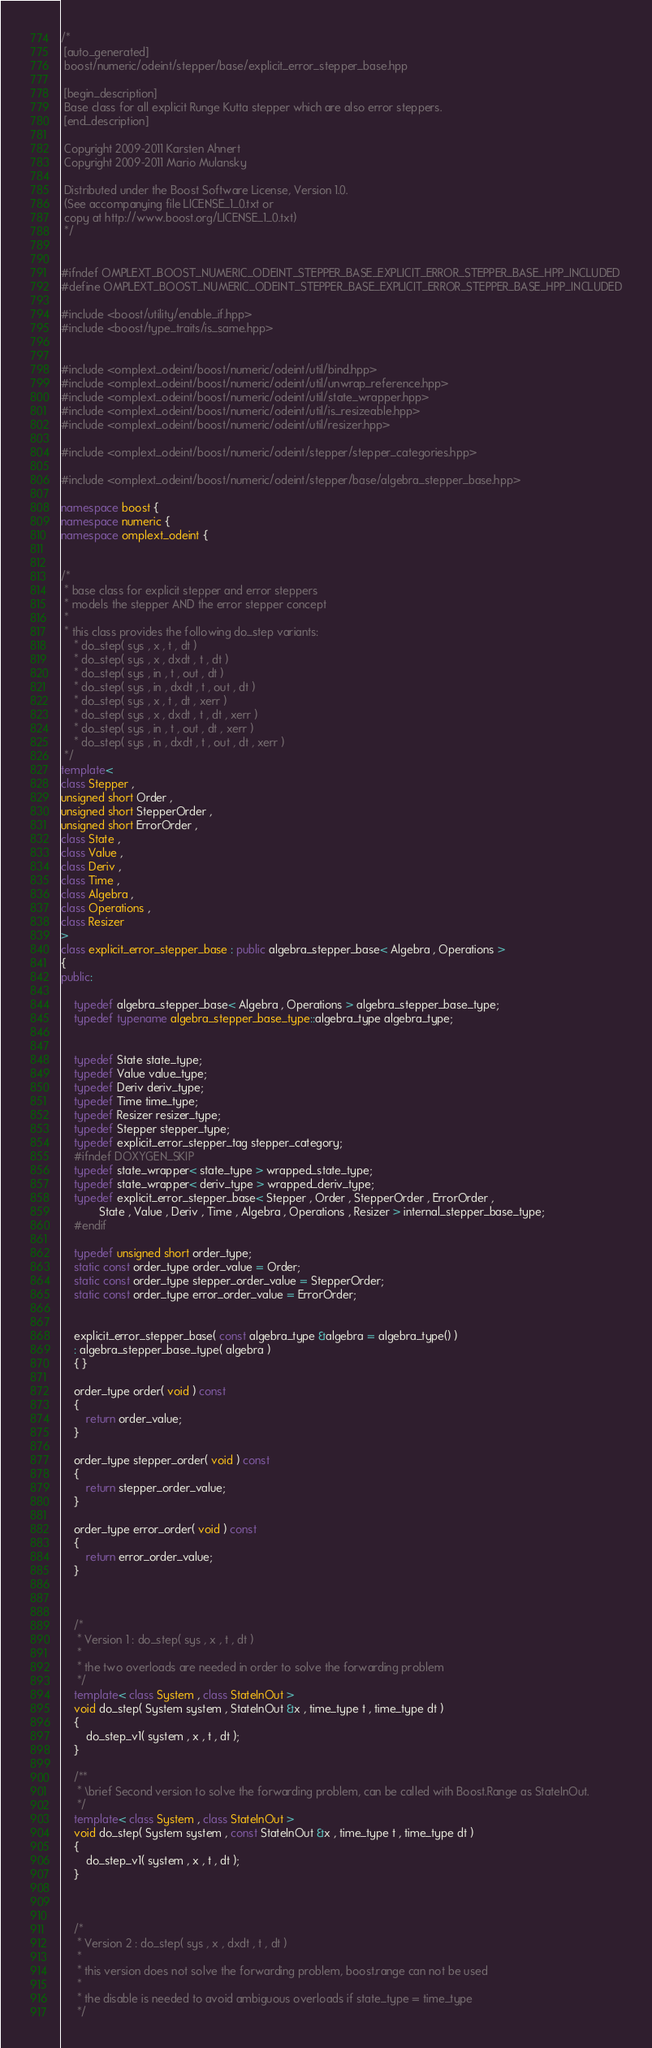<code> <loc_0><loc_0><loc_500><loc_500><_C++_>/*
 [auto_generated]
 boost/numeric/odeint/stepper/base/explicit_error_stepper_base.hpp

 [begin_description]
 Base class for all explicit Runge Kutta stepper which are also error steppers.
 [end_description]

 Copyright 2009-2011 Karsten Ahnert
 Copyright 2009-2011 Mario Mulansky

 Distributed under the Boost Software License, Version 1.0.
 (See accompanying file LICENSE_1_0.txt or
 copy at http://www.boost.org/LICENSE_1_0.txt)
 */


#ifndef OMPLEXT_BOOST_NUMERIC_ODEINT_STEPPER_BASE_EXPLICIT_ERROR_STEPPER_BASE_HPP_INCLUDED
#define OMPLEXT_BOOST_NUMERIC_ODEINT_STEPPER_BASE_EXPLICIT_ERROR_STEPPER_BASE_HPP_INCLUDED

#include <boost/utility/enable_if.hpp>
#include <boost/type_traits/is_same.hpp>


#include <omplext_odeint/boost/numeric/odeint/util/bind.hpp>
#include <omplext_odeint/boost/numeric/odeint/util/unwrap_reference.hpp>
#include <omplext_odeint/boost/numeric/odeint/util/state_wrapper.hpp>
#include <omplext_odeint/boost/numeric/odeint/util/is_resizeable.hpp>
#include <omplext_odeint/boost/numeric/odeint/util/resizer.hpp>

#include <omplext_odeint/boost/numeric/odeint/stepper/stepper_categories.hpp>

#include <omplext_odeint/boost/numeric/odeint/stepper/base/algebra_stepper_base.hpp>

namespace boost {
namespace numeric {
namespace omplext_odeint {


/*
 * base class for explicit stepper and error steppers
 * models the stepper AND the error stepper concept
 *
 * this class provides the following do_step variants:
    * do_step( sys , x , t , dt )
    * do_step( sys , x , dxdt , t , dt )
    * do_step( sys , in , t , out , dt )
    * do_step( sys , in , dxdt , t , out , dt )
    * do_step( sys , x , t , dt , xerr )
    * do_step( sys , x , dxdt , t , dt , xerr )
    * do_step( sys , in , t , out , dt , xerr )
    * do_step( sys , in , dxdt , t , out , dt , xerr )
 */
template<
class Stepper ,
unsigned short Order ,
unsigned short StepperOrder ,
unsigned short ErrorOrder ,
class State ,
class Value ,
class Deriv ,
class Time ,
class Algebra ,
class Operations ,
class Resizer
>
class explicit_error_stepper_base : public algebra_stepper_base< Algebra , Operations >
{
public:

    typedef algebra_stepper_base< Algebra , Operations > algebra_stepper_base_type;
    typedef typename algebra_stepper_base_type::algebra_type algebra_type;


    typedef State state_type;
    typedef Value value_type;
    typedef Deriv deriv_type;
    typedef Time time_type;
    typedef Resizer resizer_type;
    typedef Stepper stepper_type;
    typedef explicit_error_stepper_tag stepper_category;
    #ifndef DOXYGEN_SKIP
    typedef state_wrapper< state_type > wrapped_state_type;
    typedef state_wrapper< deriv_type > wrapped_deriv_type;
    typedef explicit_error_stepper_base< Stepper , Order , StepperOrder , ErrorOrder ,
            State , Value , Deriv , Time , Algebra , Operations , Resizer > internal_stepper_base_type;
    #endif

    typedef unsigned short order_type;
    static const order_type order_value = Order;
    static const order_type stepper_order_value = StepperOrder;
    static const order_type error_order_value = ErrorOrder;


    explicit_error_stepper_base( const algebra_type &algebra = algebra_type() )
    : algebra_stepper_base_type( algebra )
    { }

    order_type order( void ) const
    {
        return order_value;
    }

    order_type stepper_order( void ) const
    {
        return stepper_order_value;
    }

    order_type error_order( void ) const
    {
        return error_order_value;
    }



    /*
     * Version 1 : do_step( sys , x , t , dt )
     *
     * the two overloads are needed in order to solve the forwarding problem
     */
    template< class System , class StateInOut >
    void do_step( System system , StateInOut &x , time_type t , time_type dt )
    {
        do_step_v1( system , x , t , dt );
    }

    /**
     * \brief Second version to solve the forwarding problem, can be called with Boost.Range as StateInOut.
     */
    template< class System , class StateInOut >
    void do_step( System system , const StateInOut &x , time_type t , time_type dt )
    {
        do_step_v1( system , x , t , dt );
    }



    /*
     * Version 2 : do_step( sys , x , dxdt , t , dt )
     *
     * this version does not solve the forwarding problem, boost.range can not be used
     *
     * the disable is needed to avoid ambiguous overloads if state_type = time_type
     */</code> 